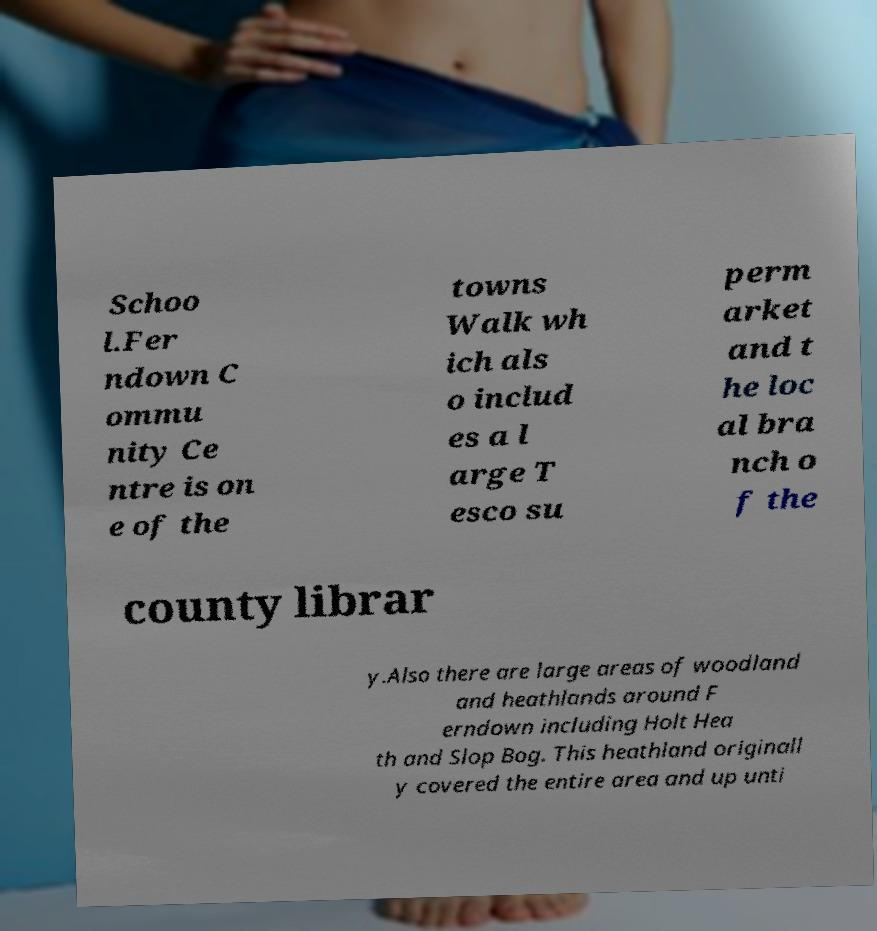Could you extract and type out the text from this image? Schoo l.Fer ndown C ommu nity Ce ntre is on e of the towns Walk wh ich als o includ es a l arge T esco su perm arket and t he loc al bra nch o f the county librar y.Also there are large areas of woodland and heathlands around F erndown including Holt Hea th and Slop Bog. This heathland originall y covered the entire area and up unti 